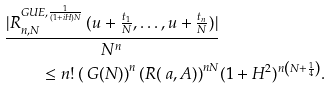<formula> <loc_0><loc_0><loc_500><loc_500>\frac { | R _ { n , N } ^ { G U E , \frac { 1 } { ( 1 + i H ) N } } \, ( u + \frac { t _ { 1 } } { N } , \dots , u + \frac { t _ { n } } { N } ) | } { N ^ { n } } & \\ \leq n ! \left ( \ G ( N ) \right ) ^ { n } \left ( R ( \ a , A ) \right ) ^ { n N } & ( 1 + H ^ { 2 } ) ^ { n \left ( N + \frac { 1 } { 4 } \right ) } .</formula> 